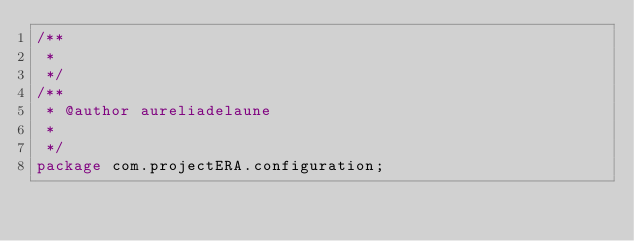<code> <loc_0><loc_0><loc_500><loc_500><_Java_>/**
 * 
 */
/**
 * @author aureliadelaune
 *
 */
package com.projectERA.configuration;</code> 